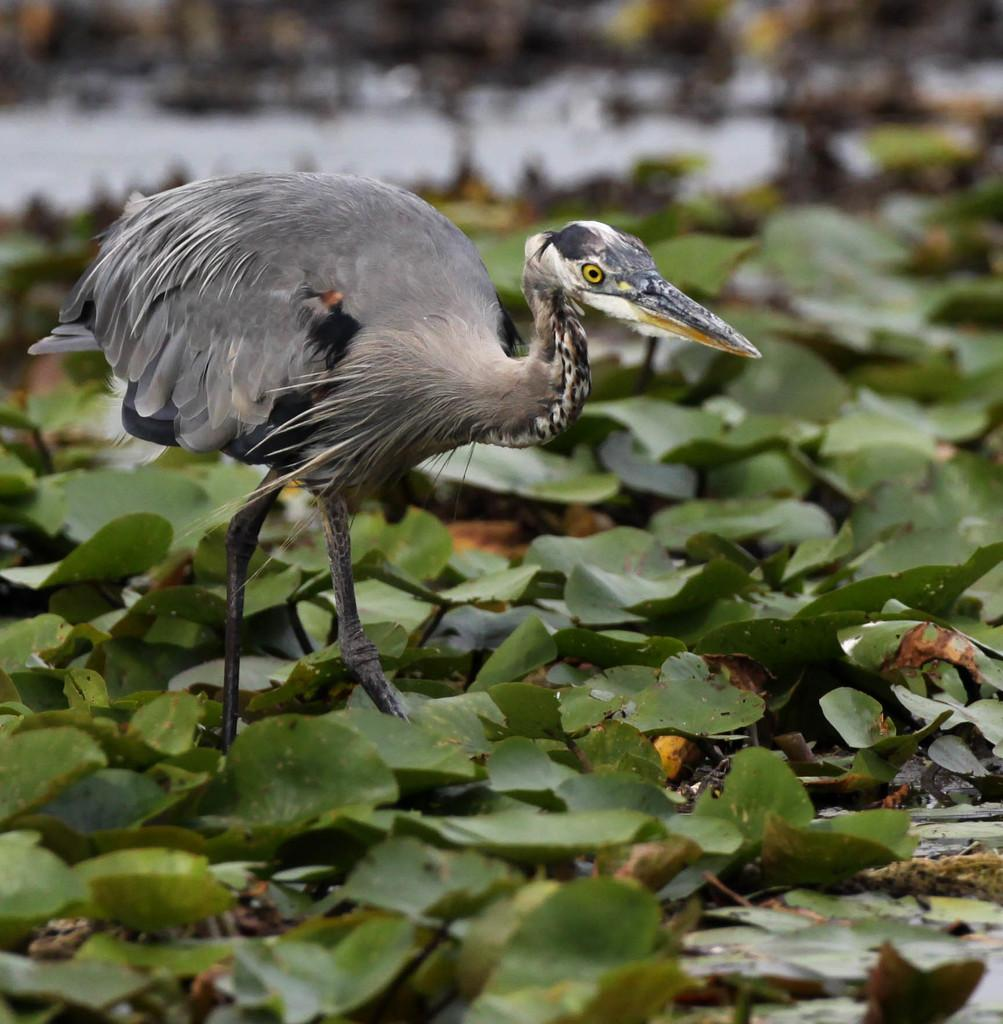What type of animal is in the image? There is a bird in the image. Where is the bird located in the image? The bird is standing on the ground. What can be seen in the background of the image? There are leaves in the background of the image. How would you describe the background of the image? The background of the image is blurred. What type of quilt is being used to cover the bird in the image? There is no quilt present in the image; the bird is standing on the ground. 